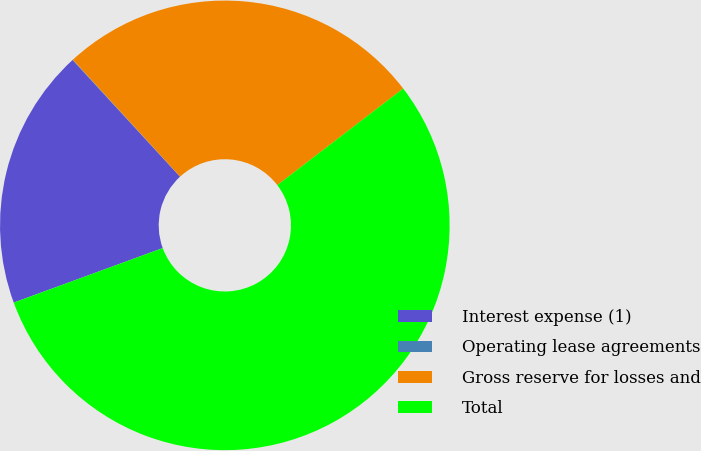Convert chart. <chart><loc_0><loc_0><loc_500><loc_500><pie_chart><fcel>Interest expense (1)<fcel>Operating lease agreements<fcel>Gross reserve for losses and<fcel>Total<nl><fcel>18.74%<fcel>0.03%<fcel>26.4%<fcel>54.83%<nl></chart> 